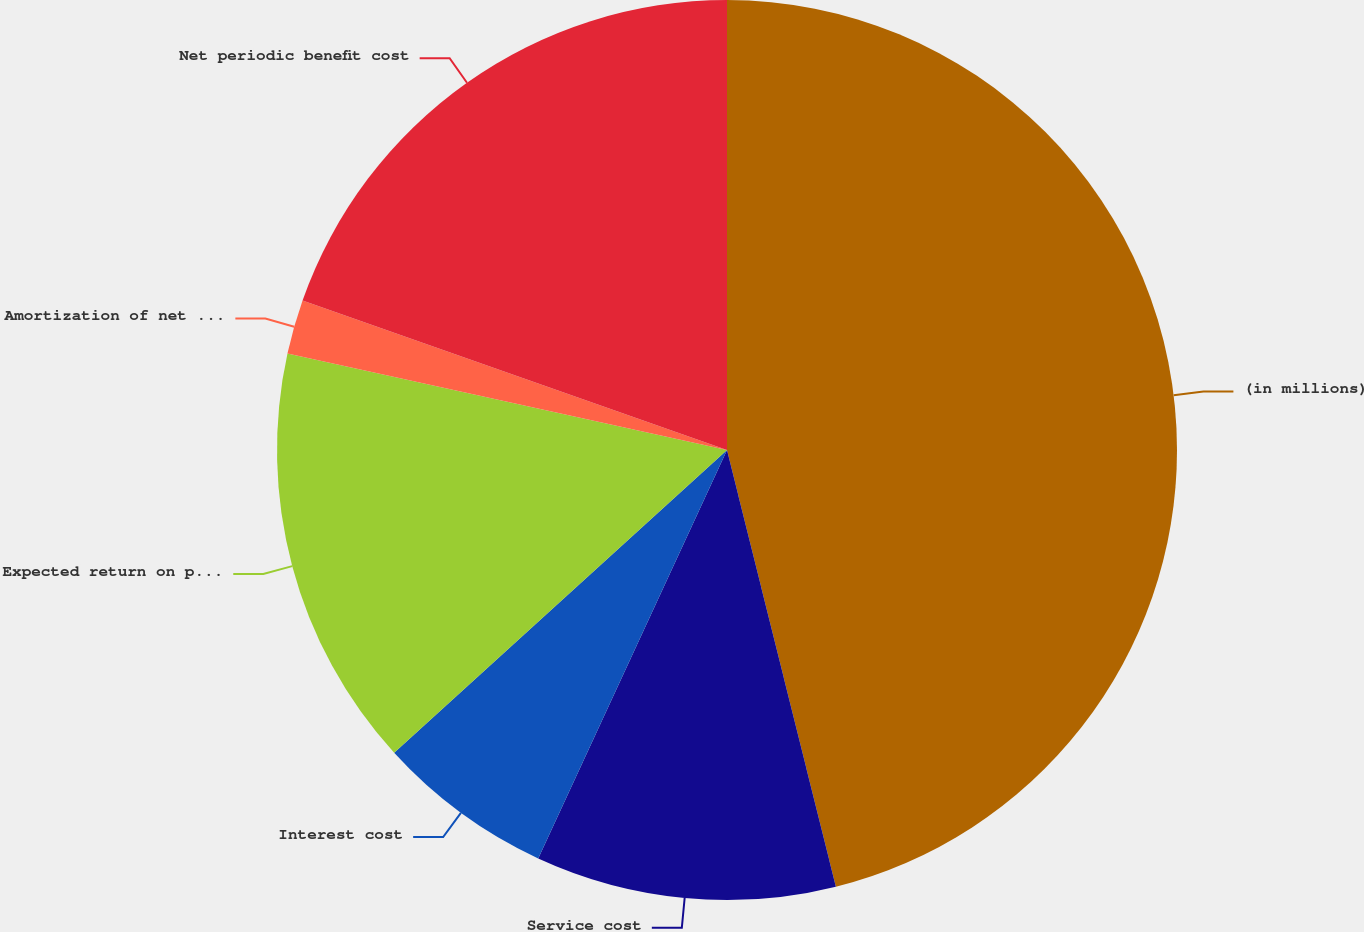Convert chart to OTSL. <chart><loc_0><loc_0><loc_500><loc_500><pie_chart><fcel>(in millions)<fcel>Service cost<fcel>Interest cost<fcel>Expected return on plan assets<fcel>Amortization of net actuarial<fcel>Net periodic benefit cost<nl><fcel>46.11%<fcel>10.78%<fcel>6.36%<fcel>15.19%<fcel>1.95%<fcel>19.61%<nl></chart> 